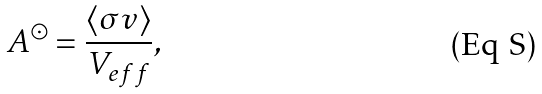Convert formula to latex. <formula><loc_0><loc_0><loc_500><loc_500>A ^ { \odot } = \frac { \langle \sigma v \rangle } { V _ { e f f } } ,</formula> 